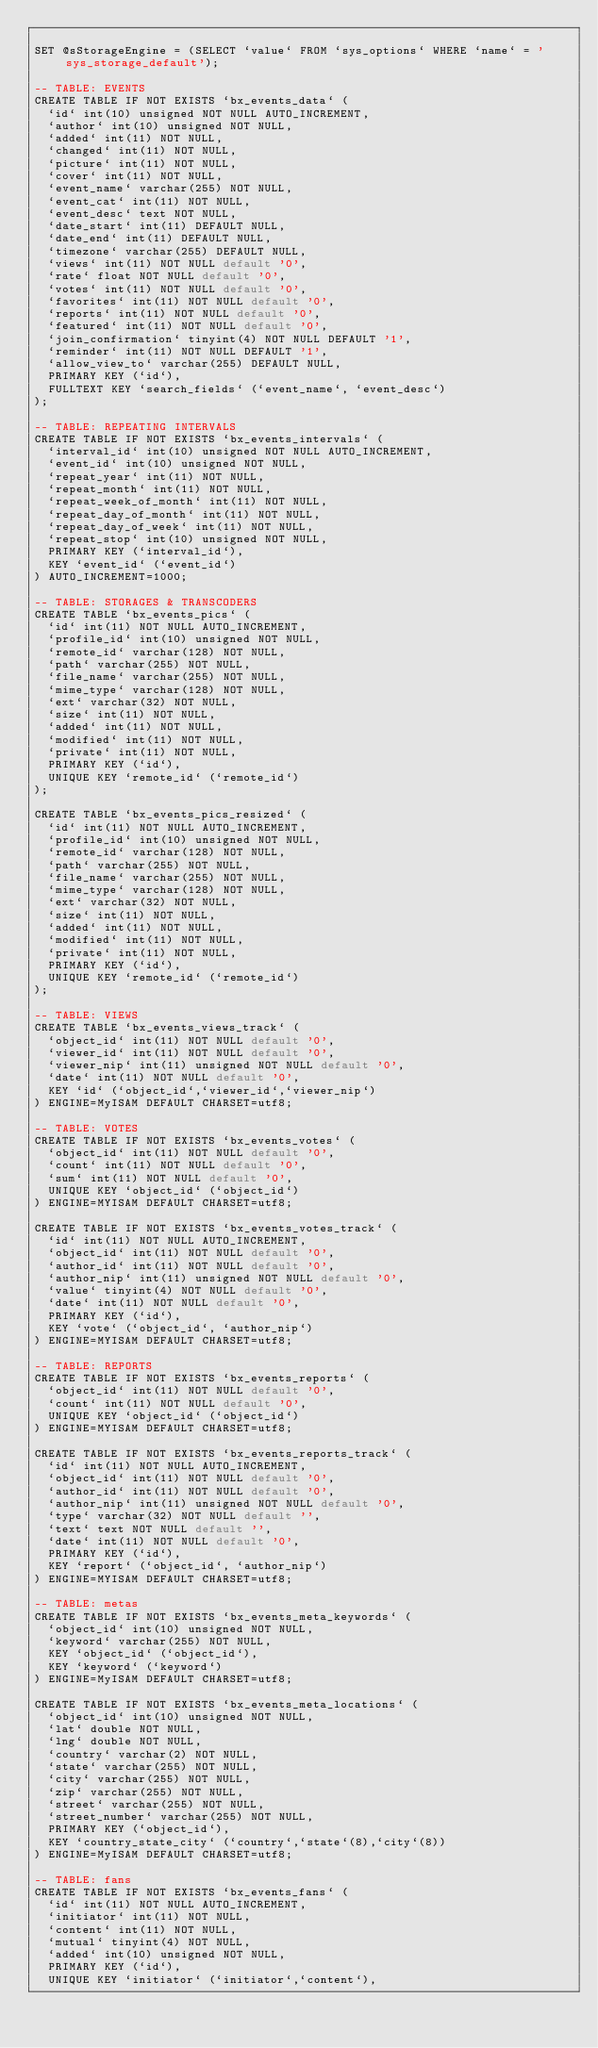Convert code to text. <code><loc_0><loc_0><loc_500><loc_500><_SQL_>
SET @sStorageEngine = (SELECT `value` FROM `sys_options` WHERE `name` = 'sys_storage_default');

-- TABLE: EVENTS
CREATE TABLE IF NOT EXISTS `bx_events_data` (
  `id` int(10) unsigned NOT NULL AUTO_INCREMENT,
  `author` int(10) unsigned NOT NULL,
  `added` int(11) NOT NULL,
  `changed` int(11) NOT NULL,
  `picture` int(11) NOT NULL,
  `cover` int(11) NOT NULL,
  `event_name` varchar(255) NOT NULL,
  `event_cat` int(11) NOT NULL,
  `event_desc` text NOT NULL,
  `date_start` int(11) DEFAULT NULL,
  `date_end` int(11) DEFAULT NULL,
  `timezone` varchar(255) DEFAULT NULL,
  `views` int(11) NOT NULL default '0',
  `rate` float NOT NULL default '0',
  `votes` int(11) NOT NULL default '0',
  `favorites` int(11) NOT NULL default '0',
  `reports` int(11) NOT NULL default '0',
  `featured` int(11) NOT NULL default '0',
  `join_confirmation` tinyint(4) NOT NULL DEFAULT '1',
  `reminder` int(11) NOT NULL DEFAULT '1',
  `allow_view_to` varchar(255) DEFAULT NULL,
  PRIMARY KEY (`id`),
  FULLTEXT KEY `search_fields` (`event_name`, `event_desc`)
);

-- TABLE: REPEATING INTERVALS
CREATE TABLE IF NOT EXISTS `bx_events_intervals` (
  `interval_id` int(10) unsigned NOT NULL AUTO_INCREMENT,
  `event_id` int(10) unsigned NOT NULL,
  `repeat_year` int(11) NOT NULL,
  `repeat_month` int(11) NOT NULL,
  `repeat_week_of_month` int(11) NOT NULL,
  `repeat_day_of_month` int(11) NOT NULL,
  `repeat_day_of_week` int(11) NOT NULL,
  `repeat_stop` int(10) unsigned NOT NULL,
  PRIMARY KEY (`interval_id`),
  KEY `event_id` (`event_id`)
) AUTO_INCREMENT=1000;

-- TABLE: STORAGES & TRANSCODERS
CREATE TABLE `bx_events_pics` (
  `id` int(11) NOT NULL AUTO_INCREMENT,
  `profile_id` int(10) unsigned NOT NULL,
  `remote_id` varchar(128) NOT NULL,
  `path` varchar(255) NOT NULL,
  `file_name` varchar(255) NOT NULL,
  `mime_type` varchar(128) NOT NULL,
  `ext` varchar(32) NOT NULL,
  `size` int(11) NOT NULL,
  `added` int(11) NOT NULL,
  `modified` int(11) NOT NULL,
  `private` int(11) NOT NULL,
  PRIMARY KEY (`id`),
  UNIQUE KEY `remote_id` (`remote_id`)
);

CREATE TABLE `bx_events_pics_resized` (
  `id` int(11) NOT NULL AUTO_INCREMENT,
  `profile_id` int(10) unsigned NOT NULL,
  `remote_id` varchar(128) NOT NULL,
  `path` varchar(255) NOT NULL,
  `file_name` varchar(255) NOT NULL,
  `mime_type` varchar(128) NOT NULL,
  `ext` varchar(32) NOT NULL,
  `size` int(11) NOT NULL,
  `added` int(11) NOT NULL,
  `modified` int(11) NOT NULL,
  `private` int(11) NOT NULL,
  PRIMARY KEY (`id`),
  UNIQUE KEY `remote_id` (`remote_id`)
);

-- TABLE: VIEWS
CREATE TABLE `bx_events_views_track` (
  `object_id` int(11) NOT NULL default '0',
  `viewer_id` int(11) NOT NULL default '0',
  `viewer_nip` int(11) unsigned NOT NULL default '0',
  `date` int(11) NOT NULL default '0',
  KEY `id` (`object_id`,`viewer_id`,`viewer_nip`)
) ENGINE=MyISAM DEFAULT CHARSET=utf8;

-- TABLE: VOTES
CREATE TABLE IF NOT EXISTS `bx_events_votes` (
  `object_id` int(11) NOT NULL default '0',
  `count` int(11) NOT NULL default '0',
  `sum` int(11) NOT NULL default '0',
  UNIQUE KEY `object_id` (`object_id`)
) ENGINE=MYISAM DEFAULT CHARSET=utf8;

CREATE TABLE IF NOT EXISTS `bx_events_votes_track` (
  `id` int(11) NOT NULL AUTO_INCREMENT,
  `object_id` int(11) NOT NULL default '0',
  `author_id` int(11) NOT NULL default '0',
  `author_nip` int(11) unsigned NOT NULL default '0',
  `value` tinyint(4) NOT NULL default '0',
  `date` int(11) NOT NULL default '0',
  PRIMARY KEY (`id`),
  KEY `vote` (`object_id`, `author_nip`)
) ENGINE=MYISAM DEFAULT CHARSET=utf8;

-- TABLE: REPORTS
CREATE TABLE IF NOT EXISTS `bx_events_reports` (
  `object_id` int(11) NOT NULL default '0',
  `count` int(11) NOT NULL default '0',
  UNIQUE KEY `object_id` (`object_id`)
) ENGINE=MYISAM DEFAULT CHARSET=utf8;

CREATE TABLE IF NOT EXISTS `bx_events_reports_track` (
  `id` int(11) NOT NULL AUTO_INCREMENT,
  `object_id` int(11) NOT NULL default '0',
  `author_id` int(11) NOT NULL default '0',
  `author_nip` int(11) unsigned NOT NULL default '0',
  `type` varchar(32) NOT NULL default '',
  `text` text NOT NULL default '',
  `date` int(11) NOT NULL default '0',
  PRIMARY KEY (`id`),
  KEY `report` (`object_id`, `author_nip`)
) ENGINE=MYISAM DEFAULT CHARSET=utf8;

-- TABLE: metas
CREATE TABLE IF NOT EXISTS `bx_events_meta_keywords` (
  `object_id` int(10) unsigned NOT NULL,
  `keyword` varchar(255) NOT NULL,
  KEY `object_id` (`object_id`),
  KEY `keyword` (`keyword`)
) ENGINE=MyISAM DEFAULT CHARSET=utf8;

CREATE TABLE IF NOT EXISTS `bx_events_meta_locations` (
  `object_id` int(10) unsigned NOT NULL,
  `lat` double NOT NULL,
  `lng` double NOT NULL,
  `country` varchar(2) NOT NULL,
  `state` varchar(255) NOT NULL,
  `city` varchar(255) NOT NULL,
  `zip` varchar(255) NOT NULL,
  `street` varchar(255) NOT NULL,
  `street_number` varchar(255) NOT NULL,
  PRIMARY KEY (`object_id`),
  KEY `country_state_city` (`country`,`state`(8),`city`(8))
) ENGINE=MyISAM DEFAULT CHARSET=utf8;

-- TABLE: fans
CREATE TABLE IF NOT EXISTS `bx_events_fans` (
  `id` int(11) NOT NULL AUTO_INCREMENT,
  `initiator` int(11) NOT NULL,
  `content` int(11) NOT NULL,
  `mutual` tinyint(4) NOT NULL,
  `added` int(10) unsigned NOT NULL,
  PRIMARY KEY (`id`),
  UNIQUE KEY `initiator` (`initiator`,`content`),</code> 